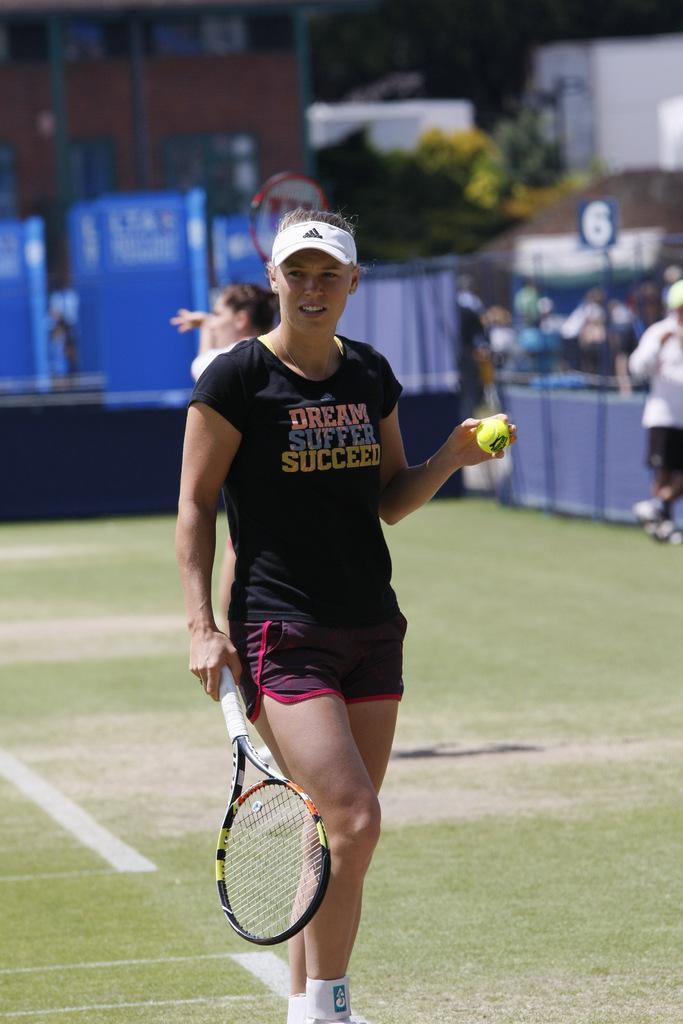Describe this image in one or two sentences. In this picture the woman is holding a tennis racket and ball and in the background audience plants 